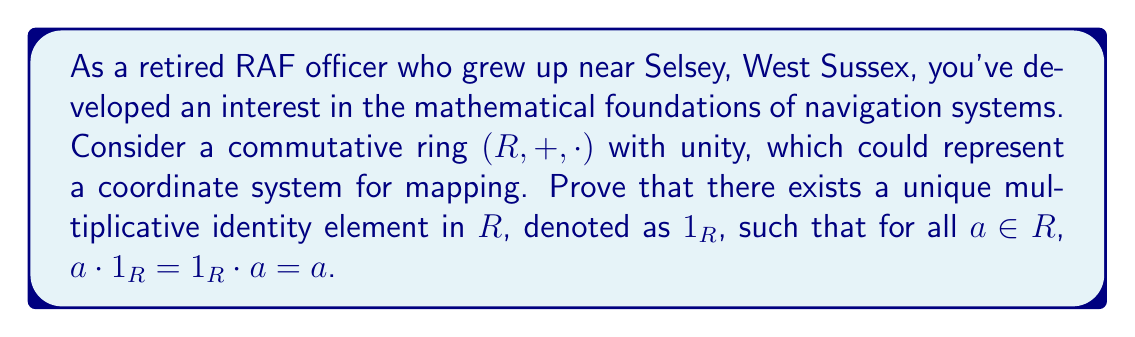Could you help me with this problem? Let's approach this proof step-by-step:

1) First, we know that $R$ has a unity, which means there exists an element $1_R \in R$ such that for all $a \in R$, $a \cdot 1_R = 1_R \cdot a = a$. This is given in the definition of a ring with unity.

2) To prove uniqueness, let's assume there exists another element $e \in R$ that also acts as a multiplicative identity. This means that for all $a \in R$, $a \cdot e = e \cdot a = a$.

3) Now, let's consider the product of $1_R$ and $e$:

   $$1_R \cdot e = 1_R$$
   (because $e$ is assumed to be an identity)

   $$1_R \cdot e = e$$
   (because $1_R$ is known to be an identity)

4) From these two equations, we can conclude:

   $$1_R = e$$

5) This proves that any element acting as a multiplicative identity must be equal to $1_R$, thus establishing the uniqueness of the multiplicative identity.

The commutativity of the ring is not explicitly used in this proof, but it ensures that $a \cdot 1_R = 1_R \cdot a$ for all $a \in R$, which is part of the definition of a multiplicative identity in a ring.
Answer: The multiplicative identity in a commutative ring with unity is unique. If $1_R$ is the given unity and $e$ is any other element acting as a multiplicative identity, then $1_R = e$, proving the uniqueness. 